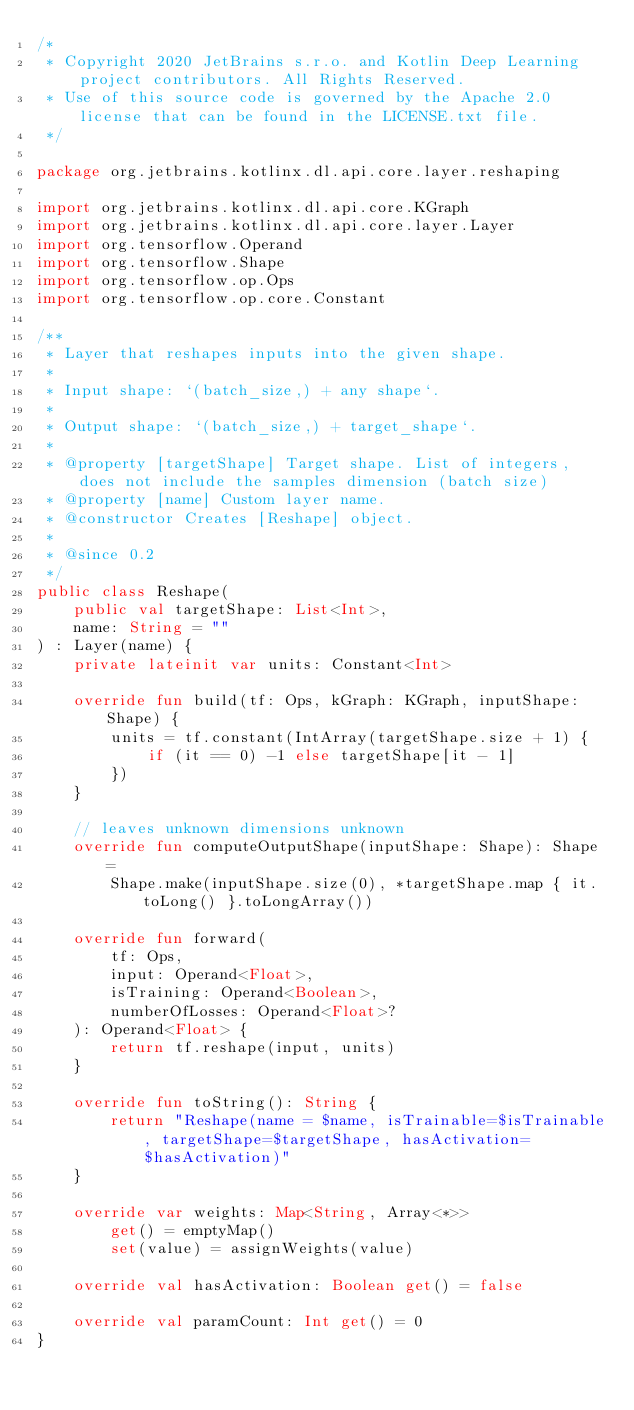Convert code to text. <code><loc_0><loc_0><loc_500><loc_500><_Kotlin_>/*
 * Copyright 2020 JetBrains s.r.o. and Kotlin Deep Learning project contributors. All Rights Reserved.
 * Use of this source code is governed by the Apache 2.0 license that can be found in the LICENSE.txt file.
 */

package org.jetbrains.kotlinx.dl.api.core.layer.reshaping

import org.jetbrains.kotlinx.dl.api.core.KGraph
import org.jetbrains.kotlinx.dl.api.core.layer.Layer
import org.tensorflow.Operand
import org.tensorflow.Shape
import org.tensorflow.op.Ops
import org.tensorflow.op.core.Constant

/**
 * Layer that reshapes inputs into the given shape.
 *
 * Input shape: `(batch_size,) + any shape`.
 *
 * Output shape: `(batch_size,) + target_shape`.
 *
 * @property [targetShape] Target shape. List of integers, does not include the samples dimension (batch size)
 * @property [name] Custom layer name.
 * @constructor Creates [Reshape] object.
 *
 * @since 0.2
 */
public class Reshape(
    public val targetShape: List<Int>,
    name: String = ""
) : Layer(name) {
    private lateinit var units: Constant<Int>

    override fun build(tf: Ops, kGraph: KGraph, inputShape: Shape) {
        units = tf.constant(IntArray(targetShape.size + 1) {
            if (it == 0) -1 else targetShape[it - 1]
        })
    }

    // leaves unknown dimensions unknown
    override fun computeOutputShape(inputShape: Shape): Shape =
        Shape.make(inputShape.size(0), *targetShape.map { it.toLong() }.toLongArray())

    override fun forward(
        tf: Ops,
        input: Operand<Float>,
        isTraining: Operand<Boolean>,
        numberOfLosses: Operand<Float>?
    ): Operand<Float> {
        return tf.reshape(input, units)
    }

    override fun toString(): String {
        return "Reshape(name = $name, isTrainable=$isTrainable, targetShape=$targetShape, hasActivation=$hasActivation)"
    }

    override var weights: Map<String, Array<*>>
        get() = emptyMap()
        set(value) = assignWeights(value)

    override val hasActivation: Boolean get() = false

    override val paramCount: Int get() = 0
}
</code> 